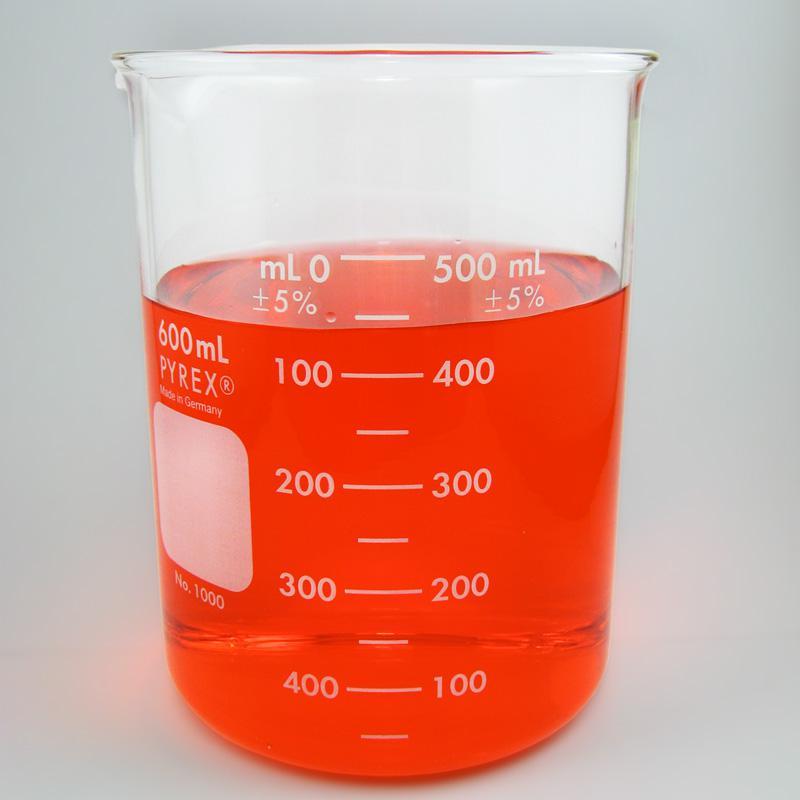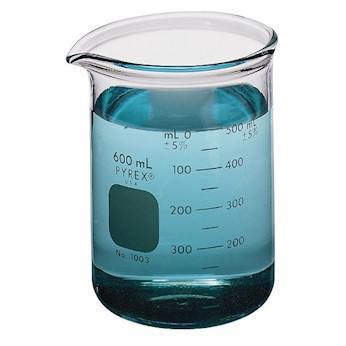The first image is the image on the left, the second image is the image on the right. Assess this claim about the two images: "One beaker is filled with blue liquid, and one beaker is filled with reddish liquid.". Correct or not? Answer yes or no. Yes. The first image is the image on the left, the second image is the image on the right. Analyze the images presented: Is the assertion "The left and right image contains the same number of full beakers." valid? Answer yes or no. Yes. 